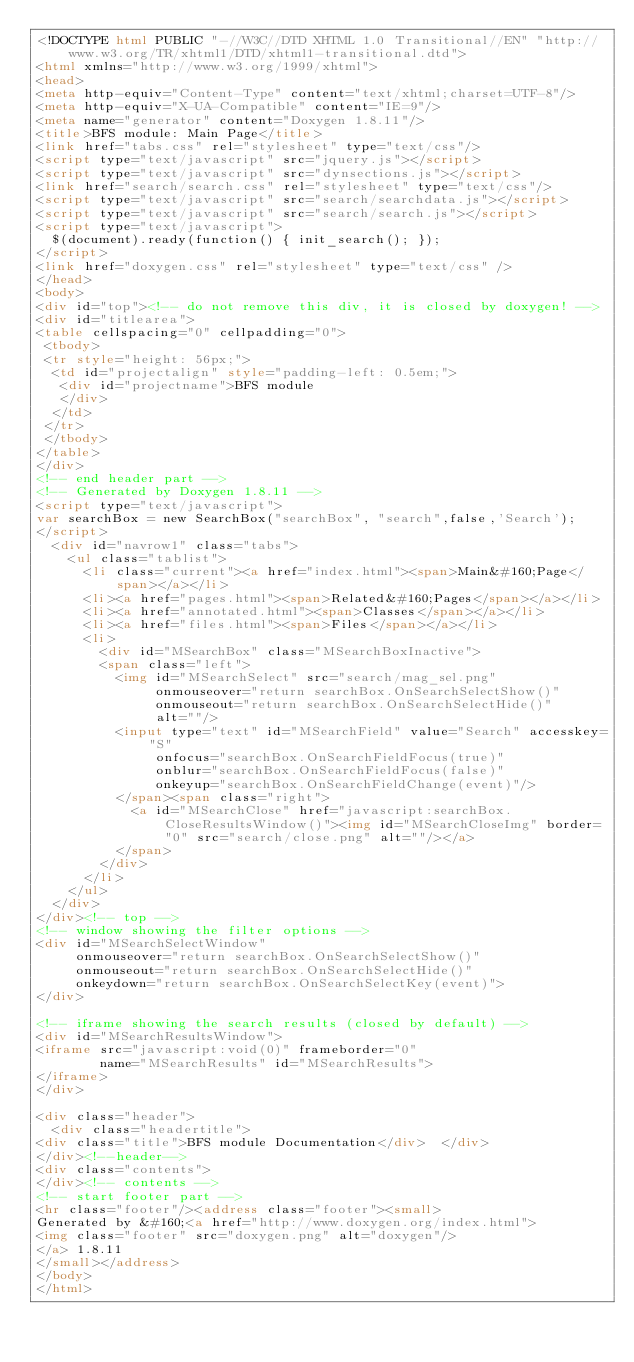<code> <loc_0><loc_0><loc_500><loc_500><_HTML_><!DOCTYPE html PUBLIC "-//W3C//DTD XHTML 1.0 Transitional//EN" "http://www.w3.org/TR/xhtml1/DTD/xhtml1-transitional.dtd">
<html xmlns="http://www.w3.org/1999/xhtml">
<head>
<meta http-equiv="Content-Type" content="text/xhtml;charset=UTF-8"/>
<meta http-equiv="X-UA-Compatible" content="IE=9"/>
<meta name="generator" content="Doxygen 1.8.11"/>
<title>BFS module: Main Page</title>
<link href="tabs.css" rel="stylesheet" type="text/css"/>
<script type="text/javascript" src="jquery.js"></script>
<script type="text/javascript" src="dynsections.js"></script>
<link href="search/search.css" rel="stylesheet" type="text/css"/>
<script type="text/javascript" src="search/searchdata.js"></script>
<script type="text/javascript" src="search/search.js"></script>
<script type="text/javascript">
  $(document).ready(function() { init_search(); });
</script>
<link href="doxygen.css" rel="stylesheet" type="text/css" />
</head>
<body>
<div id="top"><!-- do not remove this div, it is closed by doxygen! -->
<div id="titlearea">
<table cellspacing="0" cellpadding="0">
 <tbody>
 <tr style="height: 56px;">
  <td id="projectalign" style="padding-left: 0.5em;">
   <div id="projectname">BFS module
   </div>
  </td>
 </tr>
 </tbody>
</table>
</div>
<!-- end header part -->
<!-- Generated by Doxygen 1.8.11 -->
<script type="text/javascript">
var searchBox = new SearchBox("searchBox", "search",false,'Search');
</script>
  <div id="navrow1" class="tabs">
    <ul class="tablist">
      <li class="current"><a href="index.html"><span>Main&#160;Page</span></a></li>
      <li><a href="pages.html"><span>Related&#160;Pages</span></a></li>
      <li><a href="annotated.html"><span>Classes</span></a></li>
      <li><a href="files.html"><span>Files</span></a></li>
      <li>
        <div id="MSearchBox" class="MSearchBoxInactive">
        <span class="left">
          <img id="MSearchSelect" src="search/mag_sel.png"
               onmouseover="return searchBox.OnSearchSelectShow()"
               onmouseout="return searchBox.OnSearchSelectHide()"
               alt=""/>
          <input type="text" id="MSearchField" value="Search" accesskey="S"
               onfocus="searchBox.OnSearchFieldFocus(true)" 
               onblur="searchBox.OnSearchFieldFocus(false)" 
               onkeyup="searchBox.OnSearchFieldChange(event)"/>
          </span><span class="right">
            <a id="MSearchClose" href="javascript:searchBox.CloseResultsWindow()"><img id="MSearchCloseImg" border="0" src="search/close.png" alt=""/></a>
          </span>
        </div>
      </li>
    </ul>
  </div>
</div><!-- top -->
<!-- window showing the filter options -->
<div id="MSearchSelectWindow"
     onmouseover="return searchBox.OnSearchSelectShow()"
     onmouseout="return searchBox.OnSearchSelectHide()"
     onkeydown="return searchBox.OnSearchSelectKey(event)">
</div>

<!-- iframe showing the search results (closed by default) -->
<div id="MSearchResultsWindow">
<iframe src="javascript:void(0)" frameborder="0" 
        name="MSearchResults" id="MSearchResults">
</iframe>
</div>

<div class="header">
  <div class="headertitle">
<div class="title">BFS module Documentation</div>  </div>
</div><!--header-->
<div class="contents">
</div><!-- contents -->
<!-- start footer part -->
<hr class="footer"/><address class="footer"><small>
Generated by &#160;<a href="http://www.doxygen.org/index.html">
<img class="footer" src="doxygen.png" alt="doxygen"/>
</a> 1.8.11
</small></address>
</body>
</html>
</code> 